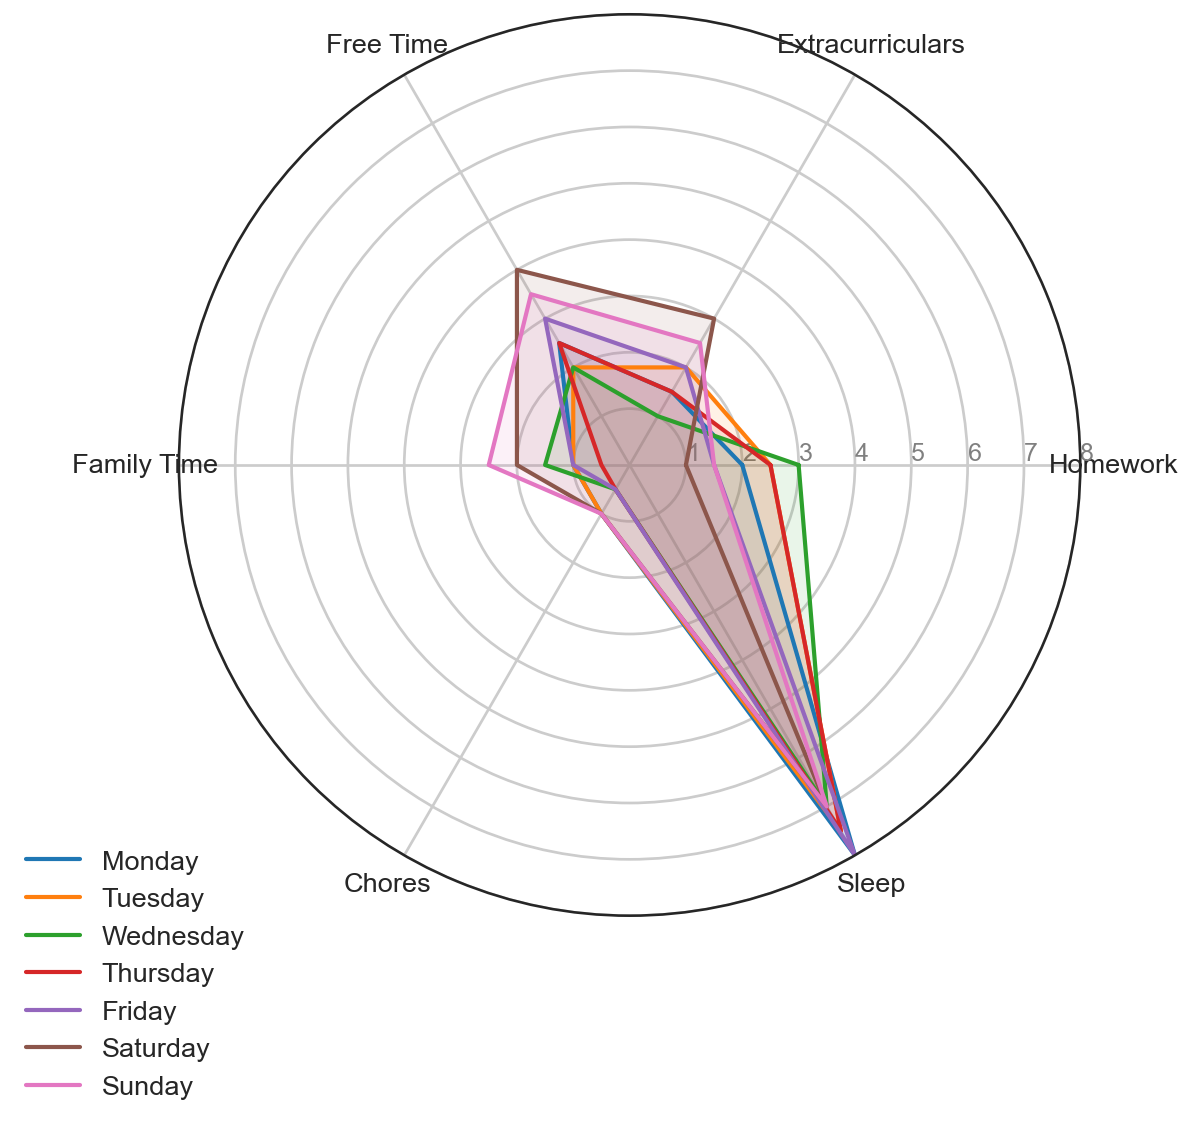Which day had the most free time? To determine this, look for the day with the highest value under the 'Free Time' category in the radar chart. The highest value for 'Free Time' is 4 on Saturday.
Answer: Saturday How does family time on Wednesday compare to Tuesday? Family time on Tuesday is 1 hour, while on Wednesday it is 1.5 hours. Comparing these values shows that Wednesday has 0.5 hour more family time than Tuesday.
Answer: Wednesday has 0.5 hour more What is the average amount of sleep over the whole week? Sum the values of sleep for all days and divide by the number of days. (8 + 7.5 + 7 + 7.5 + 8 + 7 + 7)/7 = 7.43 hours
Answer: 7.43 hours On which day are extracurricular activities performed the least? Look for the category titled 'Extracurriculars' and identify the smallest value. The smallest value is 1 on Wednesday.
Answer: Wednesday Compare the time spent on chores between Monday and Thursday. Chores on Monday is 1 hour and on Thursday is 0.5 hours. So Monday has 0.5 hour more chores than Thursday.
Answer: Monday has 0.5 hour more Which day has the most balanced distribution of activities across all categories? A balanced distribution would indicate similar lengths of the lines extending from the center for that day. Visually, Sunday appears to have the most balanced distribution as the values for all activities are more evenly distributed.
Answer: Sunday What is the total amount of time spent on homework between Monday and Thursday? Add the values for homework from Monday to Thursday: 2 + 2.5 + 3 + 2.5 = 10 hours
Answer: 10 hours Identify the day with the least amount of family time. Look for the smallest value under the 'Family Time' category. The smallest value is 0.5 on Thursday.
Answer: Thursday How does the amount of free time on Friday compare to Tuesday? Free time on Tuesday is 2 hours, while on Friday it is 3 hours. Comparing these values shows Friday has 1 hour more free time than Tuesday.
Answer: Friday has 1 hour more What is the range of sleep hours throughout the week? The range is calculated by finding the difference between the maximum and minimum values of sleep across the week. The maximum is 8 hours (Monday, Friday) and the minimum is 7 hours (Wednesday, Saturday, Sunday). Therefore, the range is 8 - 7 = 1 hour.
Answer: 1 hour 